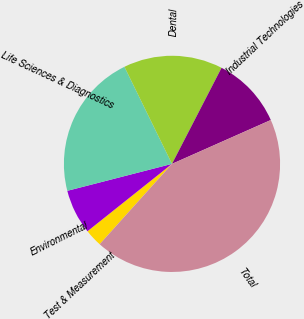Convert chart to OTSL. <chart><loc_0><loc_0><loc_500><loc_500><pie_chart><fcel>Test & Measurement<fcel>Environmental<fcel>Life Sciences & Diagnostics<fcel>Dental<fcel>Industrial Technologies<fcel>Total<nl><fcel>2.63%<fcel>6.7%<fcel>21.76%<fcel>14.83%<fcel>10.77%<fcel>43.31%<nl></chart> 